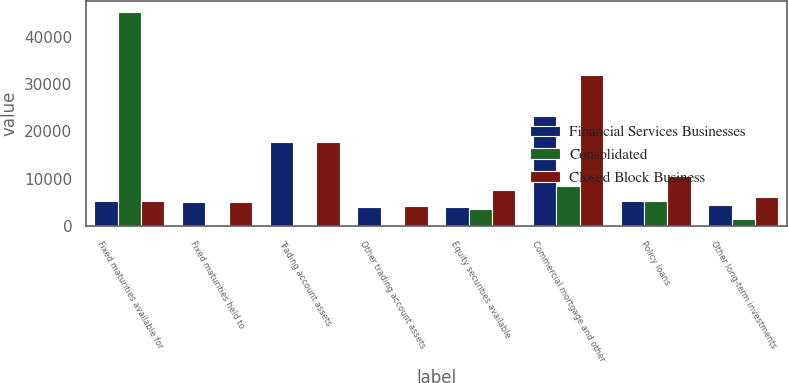Convert chart to OTSL. <chart><loc_0><loc_0><loc_500><loc_500><stacked_bar_chart><ecel><fcel>Fixed maturities available for<fcel>Fixed maturities held to<fcel>Trading account assets<fcel>Other trading account assets<fcel>Equity securities available<fcel>Commercial mortgage and other<fcel>Policy loans<fcel>Other long-term investments<nl><fcel>Financial Services Businesses<fcel>5258<fcel>5226<fcel>17771<fcel>4069<fcel>4148<fcel>23324<fcel>5290<fcel>4589<nl><fcel>Consolidated<fcel>45177<fcel>0<fcel>0<fcel>156<fcel>3593<fcel>8507<fcel>5377<fcel>1582<nl><fcel>Closed Block Business<fcel>5258<fcel>5226<fcel>17771<fcel>4225<fcel>7741<fcel>31831<fcel>10667<fcel>6171<nl></chart> 